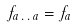Convert formula to latex. <formula><loc_0><loc_0><loc_500><loc_500>f _ { a \, . \, . \, a } = f _ { a }</formula> 